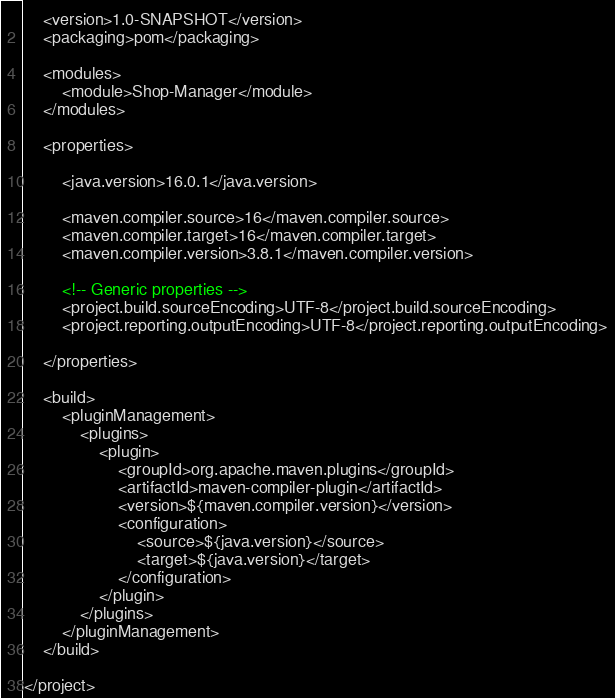<code> <loc_0><loc_0><loc_500><loc_500><_XML_>    <version>1.0-SNAPSHOT</version>
    <packaging>pom</packaging>

    <modules>
        <module>Shop-Manager</module>
    </modules>

    <properties>

        <java.version>16.0.1</java.version>

        <maven.compiler.source>16</maven.compiler.source>
        <maven.compiler.target>16</maven.compiler.target>
        <maven.compiler.version>3.8.1</maven.compiler.version>

        <!-- Generic properties -->
        <project.build.sourceEncoding>UTF-8</project.build.sourceEncoding>
        <project.reporting.outputEncoding>UTF-8</project.reporting.outputEncoding>

    </properties>

    <build>
        <pluginManagement>
            <plugins>
                <plugin>
                    <groupId>org.apache.maven.plugins</groupId>
                    <artifactId>maven-compiler-plugin</artifactId>
                    <version>${maven.compiler.version}</version>
                    <configuration>
                        <source>${java.version}</source>
                        <target>${java.version}</target>
                    </configuration>
                </plugin>
            </plugins>
        </pluginManagement>
    </build>

</project></code> 